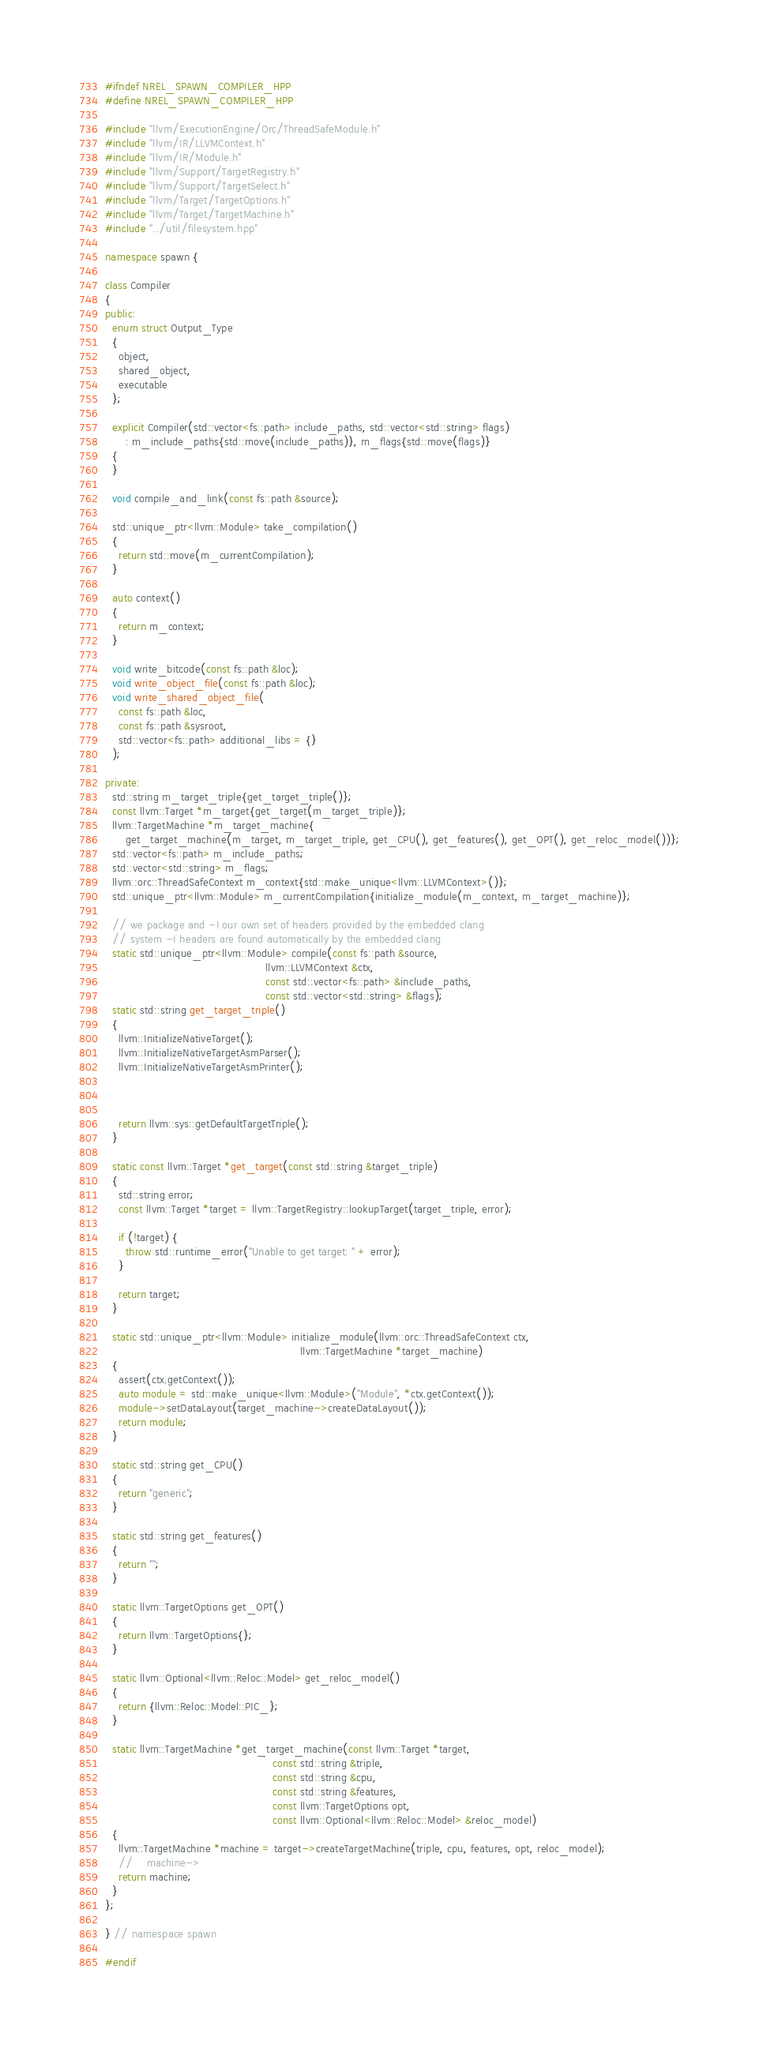<code> <loc_0><loc_0><loc_500><loc_500><_C++_>#ifndef NREL_SPAWN_COMPILER_HPP
#define NREL_SPAWN_COMPILER_HPP

#include "llvm/ExecutionEngine/Orc/ThreadSafeModule.h"
#include "llvm/IR/LLVMContext.h"
#include "llvm/IR/Module.h"
#include "llvm/Support/TargetRegistry.h"
#include "llvm/Support/TargetSelect.h"
#include "llvm/Target/TargetOptions.h"
#include "llvm/Target/TargetMachine.h"
#include "../util/filesystem.hpp"

namespace spawn {

class Compiler
{
public:
  enum struct Output_Type
  {
    object,
    shared_object,
    executable
  };

  explicit Compiler(std::vector<fs::path> include_paths, std::vector<std::string> flags)
      : m_include_paths{std::move(include_paths)}, m_flags{std::move(flags)}
  {
  }

  void compile_and_link(const fs::path &source);

  std::unique_ptr<llvm::Module> take_compilation()
  {
    return std::move(m_currentCompilation);
  }

  auto context()
  {
    return m_context;
  }

  void write_bitcode(const fs::path &loc);
  void write_object_file(const fs::path &loc);
  void write_shared_object_file(
    const fs::path &loc,
    const fs::path &sysroot,
    std::vector<fs::path> additional_libs = {}
  );

private:
  std::string m_target_triple{get_target_triple()};
  const llvm::Target *m_target{get_target(m_target_triple)};
  llvm::TargetMachine *m_target_machine{
      get_target_machine(m_target, m_target_triple, get_CPU(), get_features(), get_OPT(), get_reloc_model())};
  std::vector<fs::path> m_include_paths;
  std::vector<std::string> m_flags;
  llvm::orc::ThreadSafeContext m_context{std::make_unique<llvm::LLVMContext>()};
  std::unique_ptr<llvm::Module> m_currentCompilation{initialize_module(m_context, m_target_machine)};

  // we package and -I our own set of headers provided by the embedded clang
  // system -I headers are found automatically by the embedded clang
  static std::unique_ptr<llvm::Module> compile(const fs::path &source,
                                               llvm::LLVMContext &ctx,
                                               const std::vector<fs::path> &include_paths,
                                               const std::vector<std::string> &flags);
  static std::string get_target_triple()
  {
    llvm::InitializeNativeTarget();
    llvm::InitializeNativeTargetAsmParser();
    llvm::InitializeNativeTargetAsmPrinter();



    return llvm::sys::getDefaultTargetTriple();
  }

  static const llvm::Target *get_target(const std::string &target_triple)
  {
    std::string error;
    const llvm::Target *target = llvm::TargetRegistry::lookupTarget(target_triple, error);

    if (!target) {
      throw std::runtime_error("Unable to get target: " + error);
    }

    return target;
  }

  static std::unique_ptr<llvm::Module> initialize_module(llvm::orc::ThreadSafeContext ctx,
                                                         llvm::TargetMachine *target_machine)
  {
    assert(ctx.getContext());
    auto module = std::make_unique<llvm::Module>("Module", *ctx.getContext());
    module->setDataLayout(target_machine->createDataLayout());
    return module;
  }

  static std::string get_CPU()
  {
    return "generic";
  }

  static std::string get_features()
  {
    return "";
  }

  static llvm::TargetOptions get_OPT()
  {
    return llvm::TargetOptions{};
  }

  static llvm::Optional<llvm::Reloc::Model> get_reloc_model()
  {
    return {llvm::Reloc::Model::PIC_};
  }

  static llvm::TargetMachine *get_target_machine(const llvm::Target *target,
                                                 const std::string &triple,
                                                 const std::string &cpu,
                                                 const std::string &features,
                                                 const llvm::TargetOptions opt,
                                                 const llvm::Optional<llvm::Reloc::Model> &reloc_model)
  {
    llvm::TargetMachine *machine = target->createTargetMachine(triple, cpu, features, opt, reloc_model);
    //    machine->
    return machine;
  }
};

} // namespace spawn

#endif
</code> 